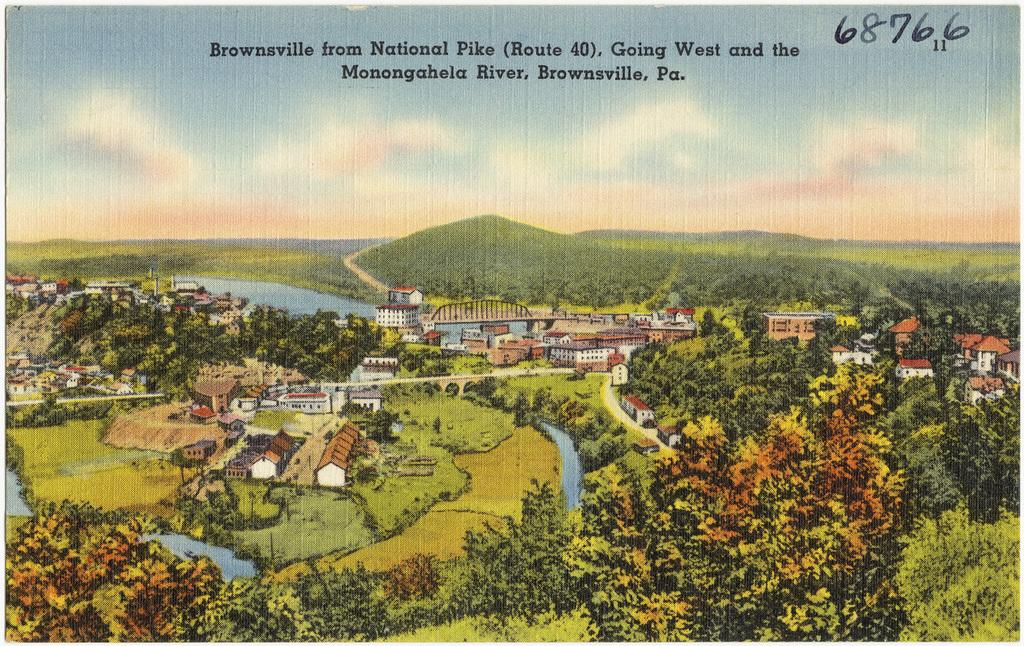Provide a one-sentence caption for the provided image. A drawing shows Monongahela River and a town in Pennsylvania. 